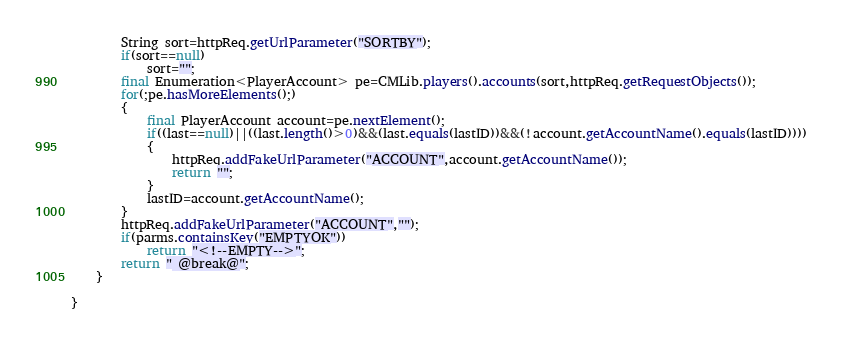<code> <loc_0><loc_0><loc_500><loc_500><_Java_>		String sort=httpReq.getUrlParameter("SORTBY");
		if(sort==null)
			sort="";
		final Enumeration<PlayerAccount> pe=CMLib.players().accounts(sort,httpReq.getRequestObjects());
		for(;pe.hasMoreElements();)
		{
			final PlayerAccount account=pe.nextElement();
			if((last==null)||((last.length()>0)&&(last.equals(lastID))&&(!account.getAccountName().equals(lastID))))
			{
				httpReq.addFakeUrlParameter("ACCOUNT",account.getAccountName());
				return "";
			}
			lastID=account.getAccountName();
		}
		httpReq.addFakeUrlParameter("ACCOUNT","");
		if(parms.containsKey("EMPTYOK"))
			return "<!--EMPTY-->";
		return " @break@";
	}

}
</code> 